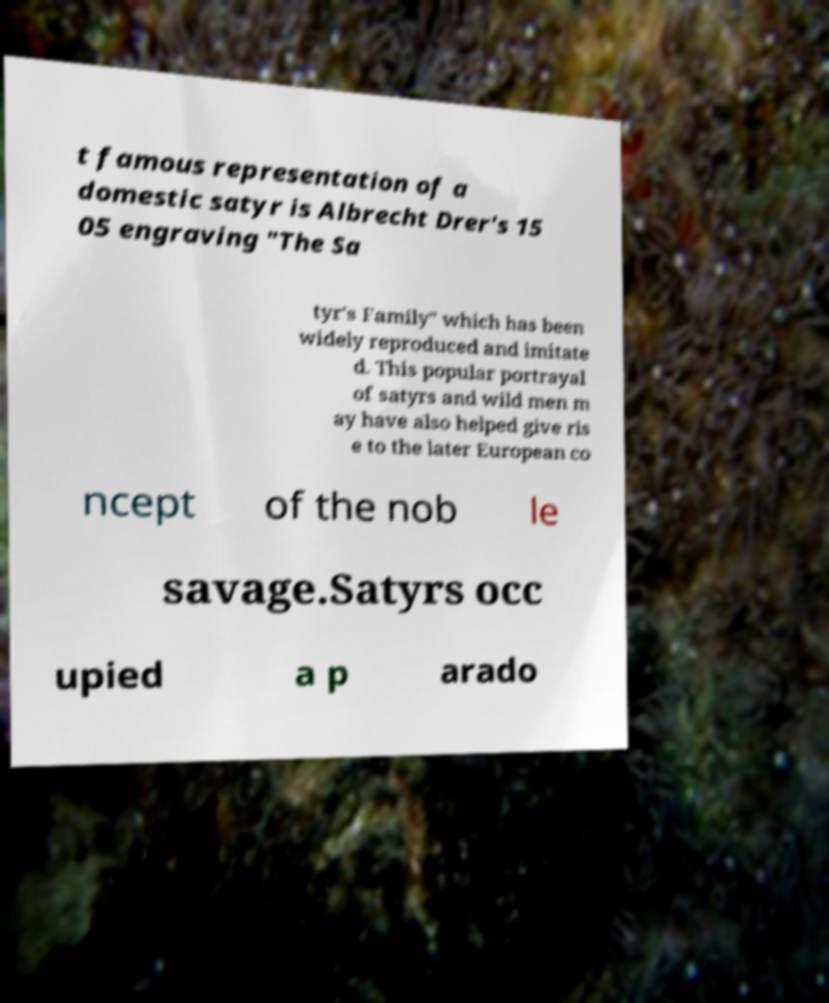Please identify and transcribe the text found in this image. t famous representation of a domestic satyr is Albrecht Drer's 15 05 engraving "The Sa tyr's Family" which has been widely reproduced and imitate d. This popular portrayal of satyrs and wild men m ay have also helped give ris e to the later European co ncept of the nob le savage.Satyrs occ upied a p arado 